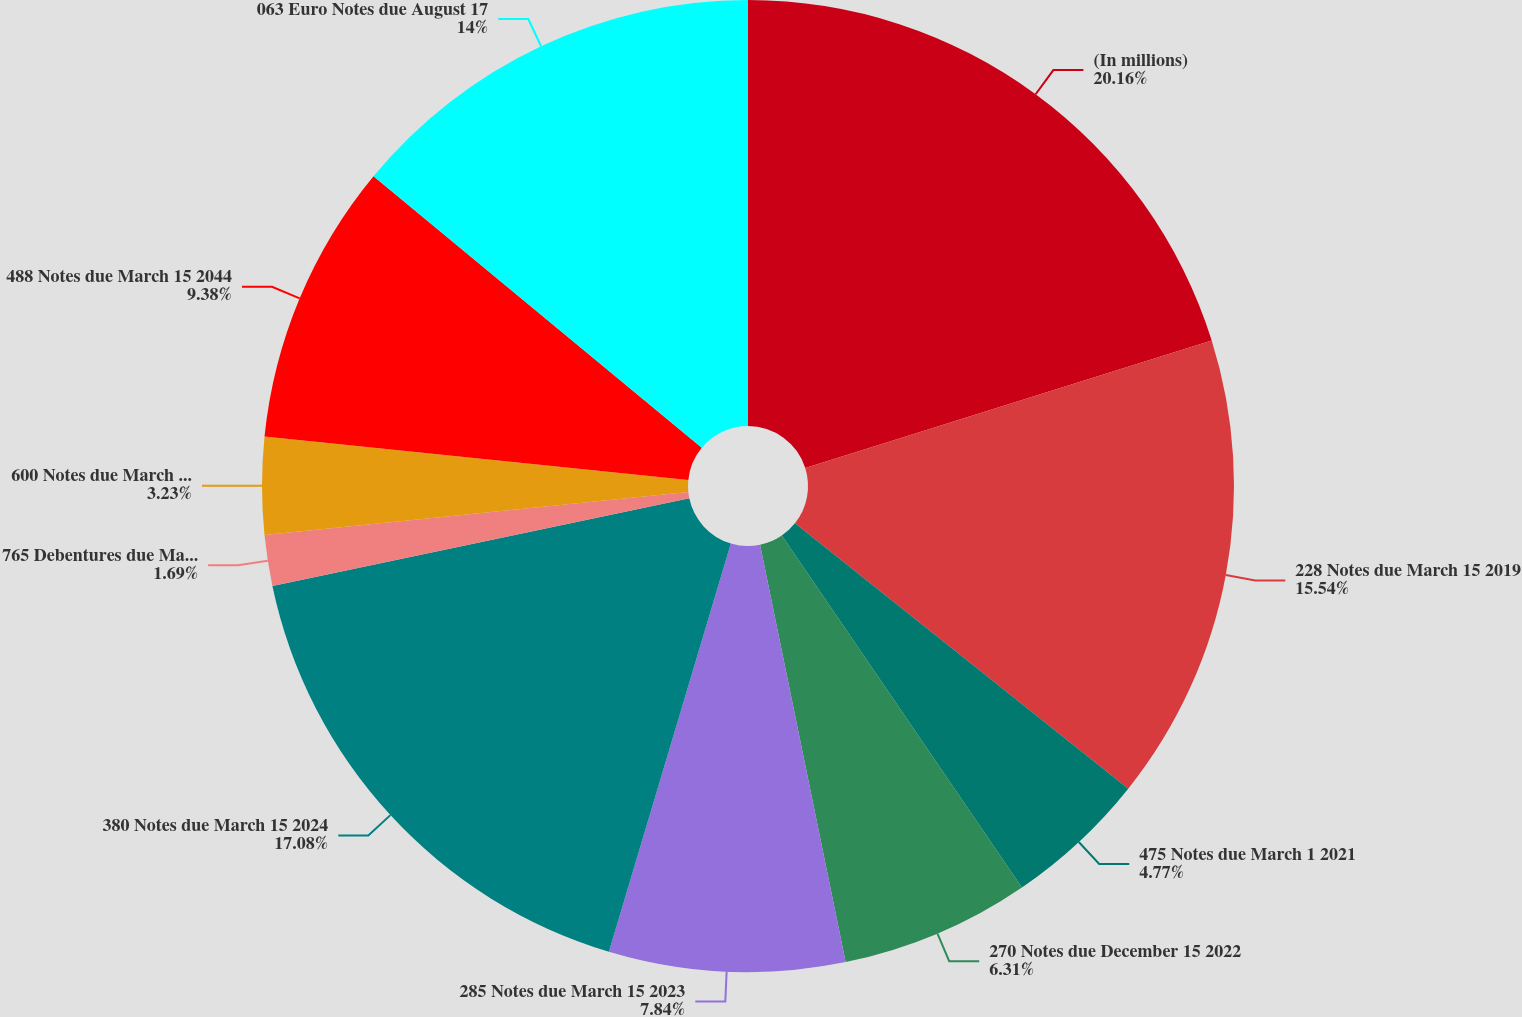Convert chart. <chart><loc_0><loc_0><loc_500><loc_500><pie_chart><fcel>(In millions)<fcel>228 Notes due March 15 2019<fcel>475 Notes due March 1 2021<fcel>270 Notes due December 15 2022<fcel>285 Notes due March 15 2023<fcel>380 Notes due March 15 2024<fcel>765 Debentures due March 1<fcel>600 Notes due March 1 2041<fcel>488 Notes due March 15 2044<fcel>063 Euro Notes due August 17<nl><fcel>20.16%<fcel>15.54%<fcel>4.77%<fcel>6.31%<fcel>7.84%<fcel>17.08%<fcel>1.69%<fcel>3.23%<fcel>9.38%<fcel>14.0%<nl></chart> 